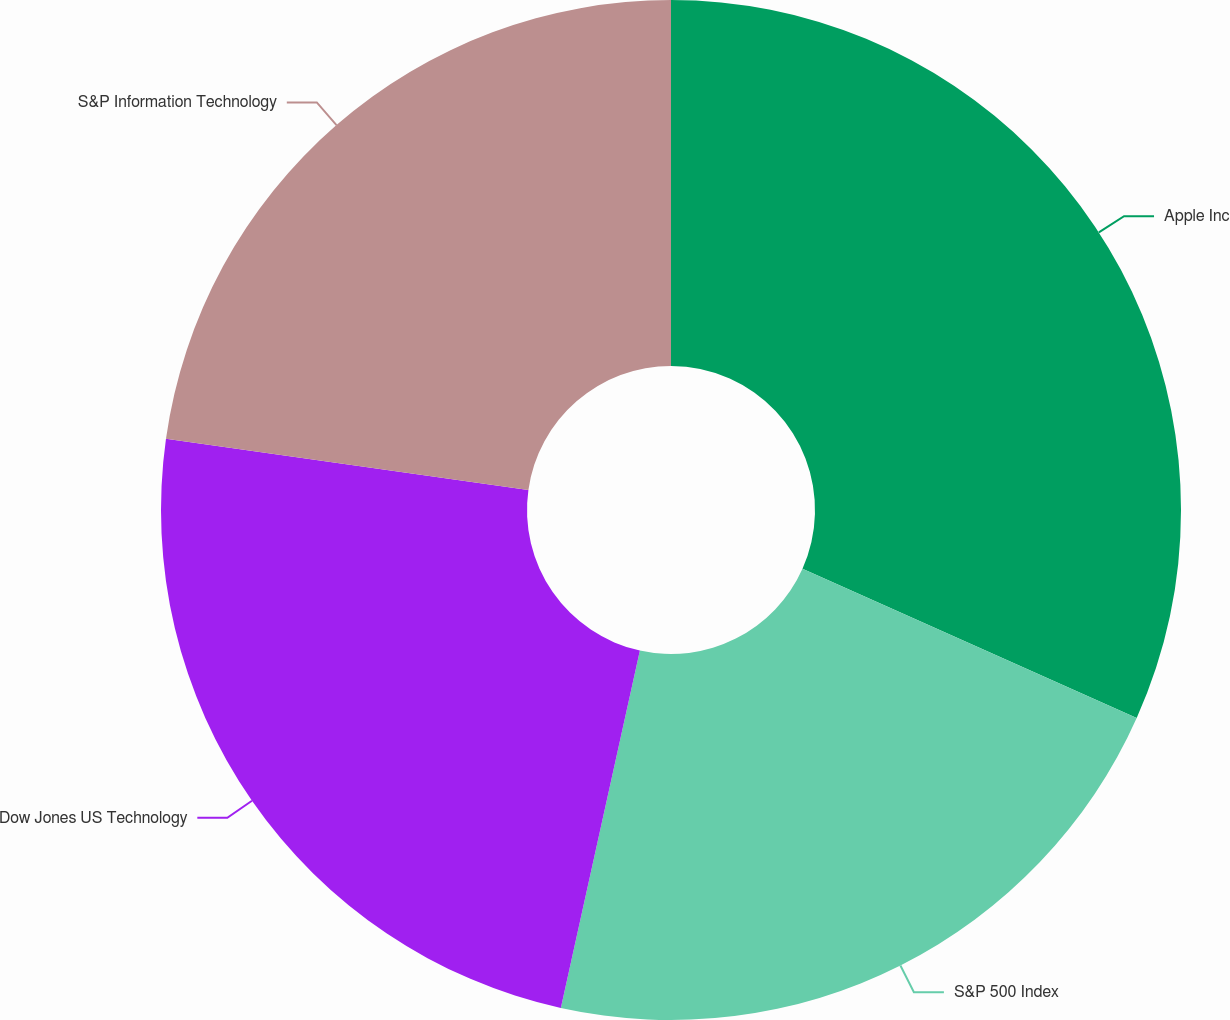<chart> <loc_0><loc_0><loc_500><loc_500><pie_chart><fcel>Apple Inc<fcel>S&P 500 Index<fcel>Dow Jones US Technology<fcel>S&P Information Technology<nl><fcel>31.68%<fcel>21.78%<fcel>23.76%<fcel>22.77%<nl></chart> 